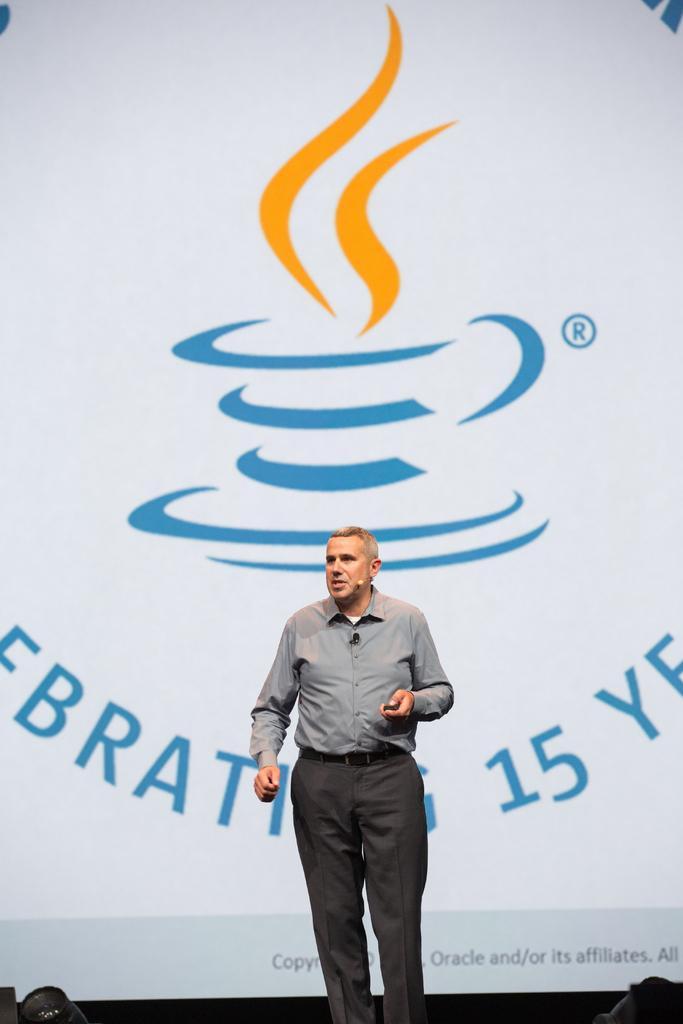How would you summarize this image in a sentence or two? In the picture we can see a man standing in shirt and trouser and talking something and behind him we can see a banner with a cup and saucer design on it with some smokes on it. 